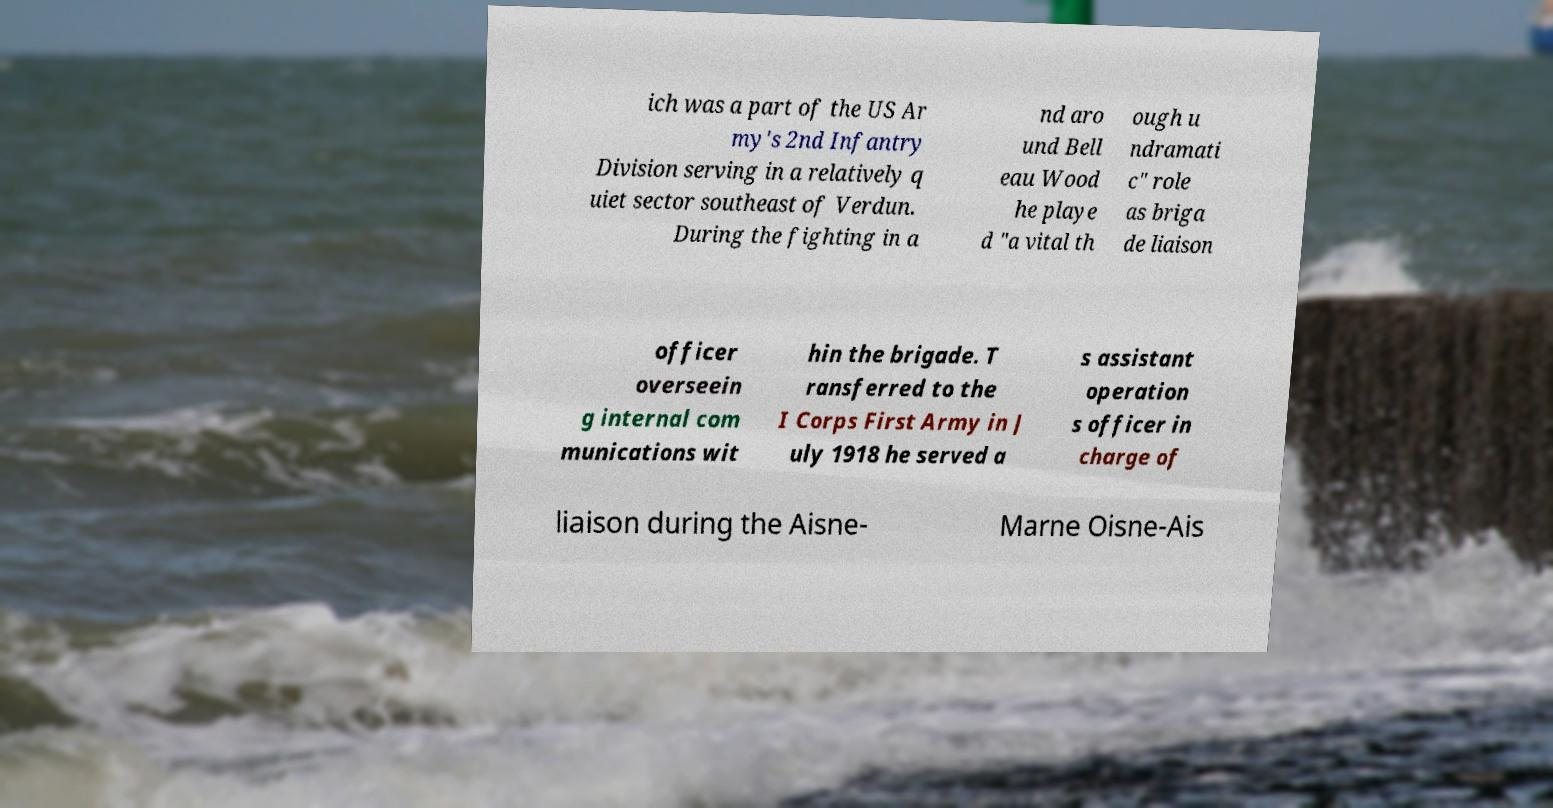Could you assist in decoding the text presented in this image and type it out clearly? ich was a part of the US Ar my's 2nd Infantry Division serving in a relatively q uiet sector southeast of Verdun. During the fighting in a nd aro und Bell eau Wood he playe d "a vital th ough u ndramati c" role as briga de liaison officer overseein g internal com munications wit hin the brigade. T ransferred to the I Corps First Army in J uly 1918 he served a s assistant operation s officer in charge of liaison during the Aisne- Marne Oisne-Ais 